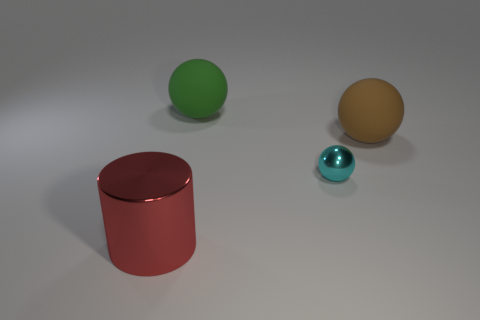Subtract all rubber balls. How many balls are left? 1 Add 2 small shiny things. How many objects exist? 6 Subtract all brown balls. How many balls are left? 2 Add 3 brown balls. How many brown balls are left? 4 Add 3 small brown rubber balls. How many small brown rubber balls exist? 3 Subtract 1 red cylinders. How many objects are left? 3 Subtract all cylinders. How many objects are left? 3 Subtract all gray cylinders. Subtract all purple balls. How many cylinders are left? 1 Subtract all small cyan metallic things. Subtract all metal cylinders. How many objects are left? 2 